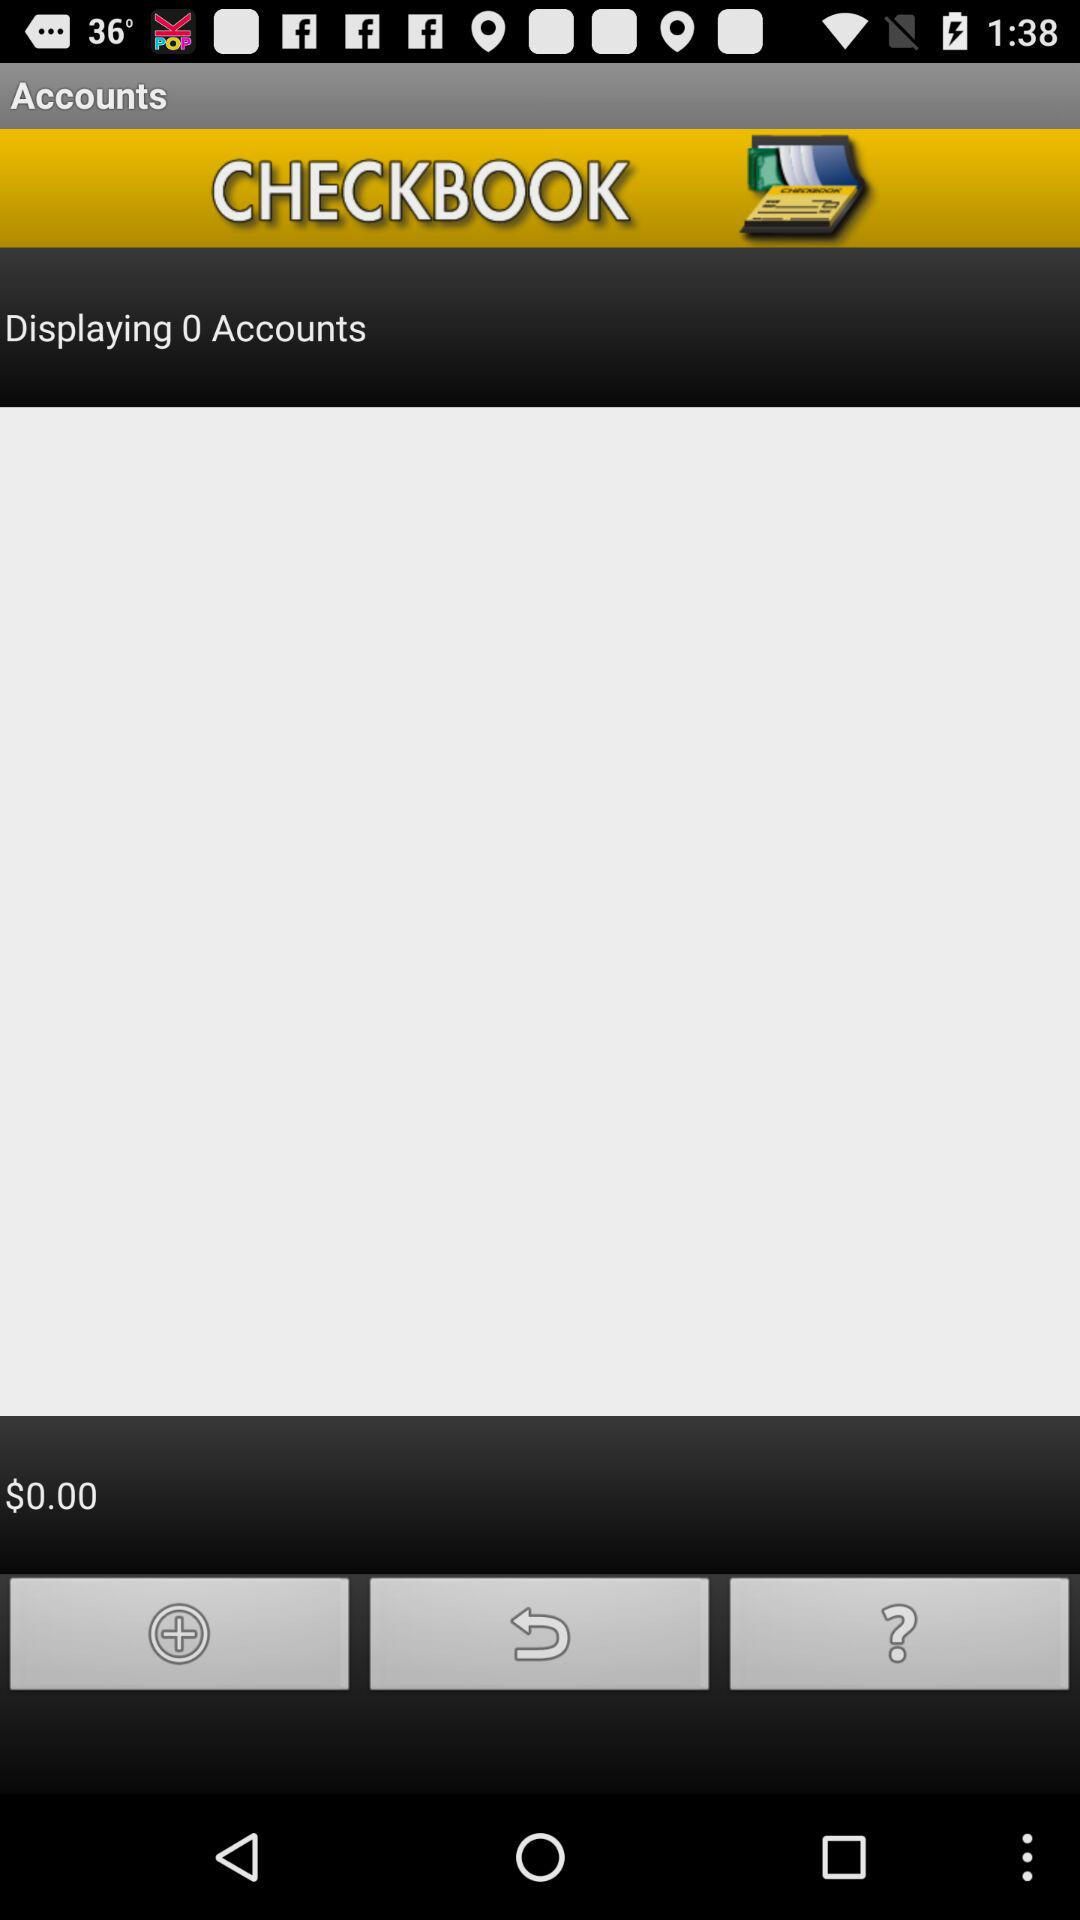What is the total number of accounts that are displayed? The total number of accounts that are displayed is 0. 